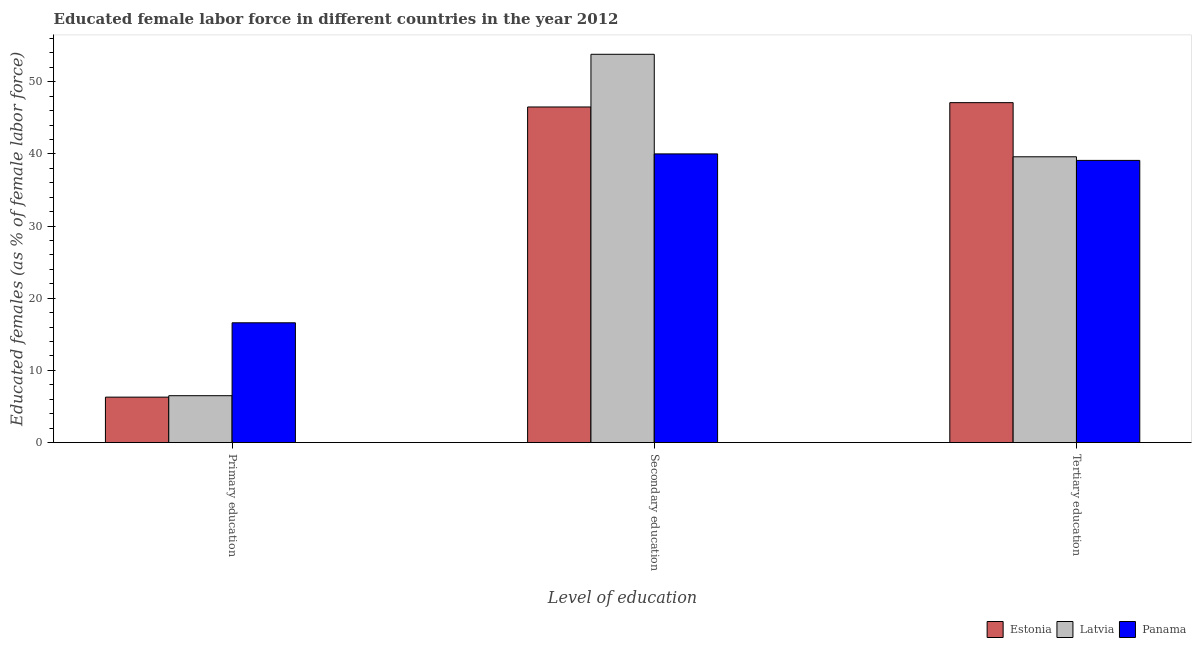How many groups of bars are there?
Provide a short and direct response. 3. Are the number of bars per tick equal to the number of legend labels?
Make the answer very short. Yes. Are the number of bars on each tick of the X-axis equal?
Keep it short and to the point. Yes. How many bars are there on the 3rd tick from the left?
Your answer should be compact. 3. How many bars are there on the 2nd tick from the right?
Your answer should be very brief. 3. What is the label of the 2nd group of bars from the left?
Provide a short and direct response. Secondary education. What is the percentage of female labor force who received tertiary education in Latvia?
Ensure brevity in your answer.  39.6. Across all countries, what is the maximum percentage of female labor force who received secondary education?
Your answer should be very brief. 53.8. Across all countries, what is the minimum percentage of female labor force who received tertiary education?
Give a very brief answer. 39.1. In which country was the percentage of female labor force who received tertiary education maximum?
Offer a very short reply. Estonia. In which country was the percentage of female labor force who received secondary education minimum?
Your response must be concise. Panama. What is the total percentage of female labor force who received tertiary education in the graph?
Provide a short and direct response. 125.8. What is the difference between the percentage of female labor force who received primary education in Estonia and that in Panama?
Provide a succinct answer. -10.3. What is the difference between the percentage of female labor force who received tertiary education in Estonia and the percentage of female labor force who received primary education in Latvia?
Provide a short and direct response. 40.6. What is the average percentage of female labor force who received secondary education per country?
Offer a terse response. 46.77. What is the difference between the percentage of female labor force who received secondary education and percentage of female labor force who received primary education in Panama?
Your answer should be compact. 23.4. What is the ratio of the percentage of female labor force who received primary education in Panama to that in Latvia?
Offer a terse response. 2.55. Is the percentage of female labor force who received primary education in Panama less than that in Estonia?
Keep it short and to the point. No. What is the difference between the highest and the second highest percentage of female labor force who received tertiary education?
Your answer should be compact. 7.5. What is the difference between the highest and the lowest percentage of female labor force who received secondary education?
Offer a terse response. 13.8. In how many countries, is the percentage of female labor force who received tertiary education greater than the average percentage of female labor force who received tertiary education taken over all countries?
Provide a short and direct response. 1. What does the 1st bar from the left in Primary education represents?
Your response must be concise. Estonia. What does the 2nd bar from the right in Tertiary education represents?
Make the answer very short. Latvia. Is it the case that in every country, the sum of the percentage of female labor force who received primary education and percentage of female labor force who received secondary education is greater than the percentage of female labor force who received tertiary education?
Your answer should be compact. Yes. How many bars are there?
Your answer should be compact. 9. What is the difference between two consecutive major ticks on the Y-axis?
Provide a short and direct response. 10. Does the graph contain any zero values?
Your answer should be very brief. No. What is the title of the graph?
Offer a terse response. Educated female labor force in different countries in the year 2012. What is the label or title of the X-axis?
Provide a succinct answer. Level of education. What is the label or title of the Y-axis?
Keep it short and to the point. Educated females (as % of female labor force). What is the Educated females (as % of female labor force) of Estonia in Primary education?
Provide a short and direct response. 6.3. What is the Educated females (as % of female labor force) of Latvia in Primary education?
Provide a succinct answer. 6.5. What is the Educated females (as % of female labor force) in Panama in Primary education?
Offer a terse response. 16.6. What is the Educated females (as % of female labor force) of Estonia in Secondary education?
Your answer should be compact. 46.5. What is the Educated females (as % of female labor force) of Latvia in Secondary education?
Your response must be concise. 53.8. What is the Educated females (as % of female labor force) of Estonia in Tertiary education?
Your response must be concise. 47.1. What is the Educated females (as % of female labor force) in Latvia in Tertiary education?
Offer a very short reply. 39.6. What is the Educated females (as % of female labor force) in Panama in Tertiary education?
Your answer should be very brief. 39.1. Across all Level of education, what is the maximum Educated females (as % of female labor force) of Estonia?
Offer a terse response. 47.1. Across all Level of education, what is the maximum Educated females (as % of female labor force) in Latvia?
Your answer should be very brief. 53.8. Across all Level of education, what is the minimum Educated females (as % of female labor force) in Estonia?
Keep it short and to the point. 6.3. Across all Level of education, what is the minimum Educated females (as % of female labor force) of Panama?
Your response must be concise. 16.6. What is the total Educated females (as % of female labor force) of Estonia in the graph?
Give a very brief answer. 99.9. What is the total Educated females (as % of female labor force) in Latvia in the graph?
Your answer should be compact. 99.9. What is the total Educated females (as % of female labor force) in Panama in the graph?
Offer a terse response. 95.7. What is the difference between the Educated females (as % of female labor force) in Estonia in Primary education and that in Secondary education?
Offer a very short reply. -40.2. What is the difference between the Educated females (as % of female labor force) in Latvia in Primary education and that in Secondary education?
Your answer should be compact. -47.3. What is the difference between the Educated females (as % of female labor force) of Panama in Primary education and that in Secondary education?
Provide a short and direct response. -23.4. What is the difference between the Educated females (as % of female labor force) in Estonia in Primary education and that in Tertiary education?
Make the answer very short. -40.8. What is the difference between the Educated females (as % of female labor force) of Latvia in Primary education and that in Tertiary education?
Your answer should be compact. -33.1. What is the difference between the Educated females (as % of female labor force) of Panama in Primary education and that in Tertiary education?
Your answer should be compact. -22.5. What is the difference between the Educated females (as % of female labor force) of Latvia in Secondary education and that in Tertiary education?
Ensure brevity in your answer.  14.2. What is the difference between the Educated females (as % of female labor force) in Estonia in Primary education and the Educated females (as % of female labor force) in Latvia in Secondary education?
Offer a terse response. -47.5. What is the difference between the Educated females (as % of female labor force) of Estonia in Primary education and the Educated females (as % of female labor force) of Panama in Secondary education?
Make the answer very short. -33.7. What is the difference between the Educated females (as % of female labor force) of Latvia in Primary education and the Educated females (as % of female labor force) of Panama in Secondary education?
Give a very brief answer. -33.5. What is the difference between the Educated females (as % of female labor force) of Estonia in Primary education and the Educated females (as % of female labor force) of Latvia in Tertiary education?
Your answer should be compact. -33.3. What is the difference between the Educated females (as % of female labor force) in Estonia in Primary education and the Educated females (as % of female labor force) in Panama in Tertiary education?
Offer a terse response. -32.8. What is the difference between the Educated females (as % of female labor force) of Latvia in Primary education and the Educated females (as % of female labor force) of Panama in Tertiary education?
Provide a short and direct response. -32.6. What is the difference between the Educated females (as % of female labor force) in Estonia in Secondary education and the Educated females (as % of female labor force) in Latvia in Tertiary education?
Offer a terse response. 6.9. What is the difference between the Educated females (as % of female labor force) in Estonia in Secondary education and the Educated females (as % of female labor force) in Panama in Tertiary education?
Provide a short and direct response. 7.4. What is the average Educated females (as % of female labor force) of Estonia per Level of education?
Make the answer very short. 33.3. What is the average Educated females (as % of female labor force) in Latvia per Level of education?
Give a very brief answer. 33.3. What is the average Educated females (as % of female labor force) in Panama per Level of education?
Provide a short and direct response. 31.9. What is the difference between the Educated females (as % of female labor force) of Estonia and Educated females (as % of female labor force) of Latvia in Primary education?
Provide a succinct answer. -0.2. What is the difference between the Educated females (as % of female labor force) of Estonia and Educated females (as % of female labor force) of Latvia in Secondary education?
Your answer should be very brief. -7.3. What is the difference between the Educated females (as % of female labor force) in Estonia and Educated females (as % of female labor force) in Panama in Secondary education?
Offer a terse response. 6.5. What is the ratio of the Educated females (as % of female labor force) of Estonia in Primary education to that in Secondary education?
Give a very brief answer. 0.14. What is the ratio of the Educated females (as % of female labor force) of Latvia in Primary education to that in Secondary education?
Keep it short and to the point. 0.12. What is the ratio of the Educated females (as % of female labor force) in Panama in Primary education to that in Secondary education?
Offer a terse response. 0.41. What is the ratio of the Educated females (as % of female labor force) of Estonia in Primary education to that in Tertiary education?
Ensure brevity in your answer.  0.13. What is the ratio of the Educated females (as % of female labor force) in Latvia in Primary education to that in Tertiary education?
Offer a terse response. 0.16. What is the ratio of the Educated females (as % of female labor force) in Panama in Primary education to that in Tertiary education?
Make the answer very short. 0.42. What is the ratio of the Educated females (as % of female labor force) in Estonia in Secondary education to that in Tertiary education?
Ensure brevity in your answer.  0.99. What is the ratio of the Educated females (as % of female labor force) in Latvia in Secondary education to that in Tertiary education?
Offer a very short reply. 1.36. What is the difference between the highest and the second highest Educated females (as % of female labor force) of Latvia?
Make the answer very short. 14.2. What is the difference between the highest and the lowest Educated females (as % of female labor force) of Estonia?
Provide a succinct answer. 40.8. What is the difference between the highest and the lowest Educated females (as % of female labor force) of Latvia?
Your answer should be very brief. 47.3. What is the difference between the highest and the lowest Educated females (as % of female labor force) in Panama?
Ensure brevity in your answer.  23.4. 